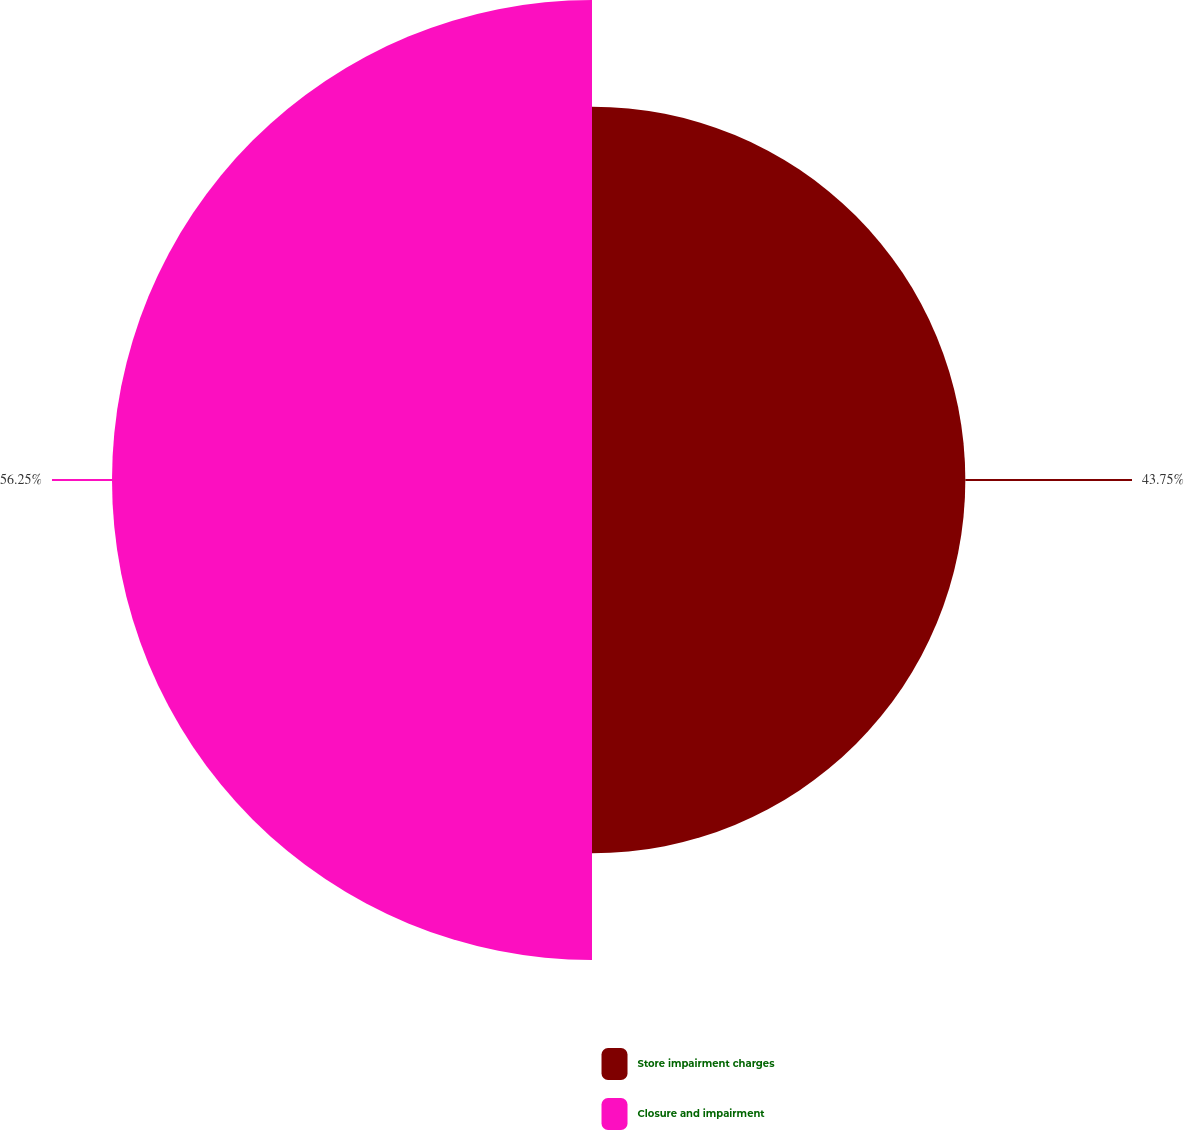<chart> <loc_0><loc_0><loc_500><loc_500><pie_chart><fcel>Store impairment charges<fcel>Closure and impairment<nl><fcel>43.75%<fcel>56.25%<nl></chart> 